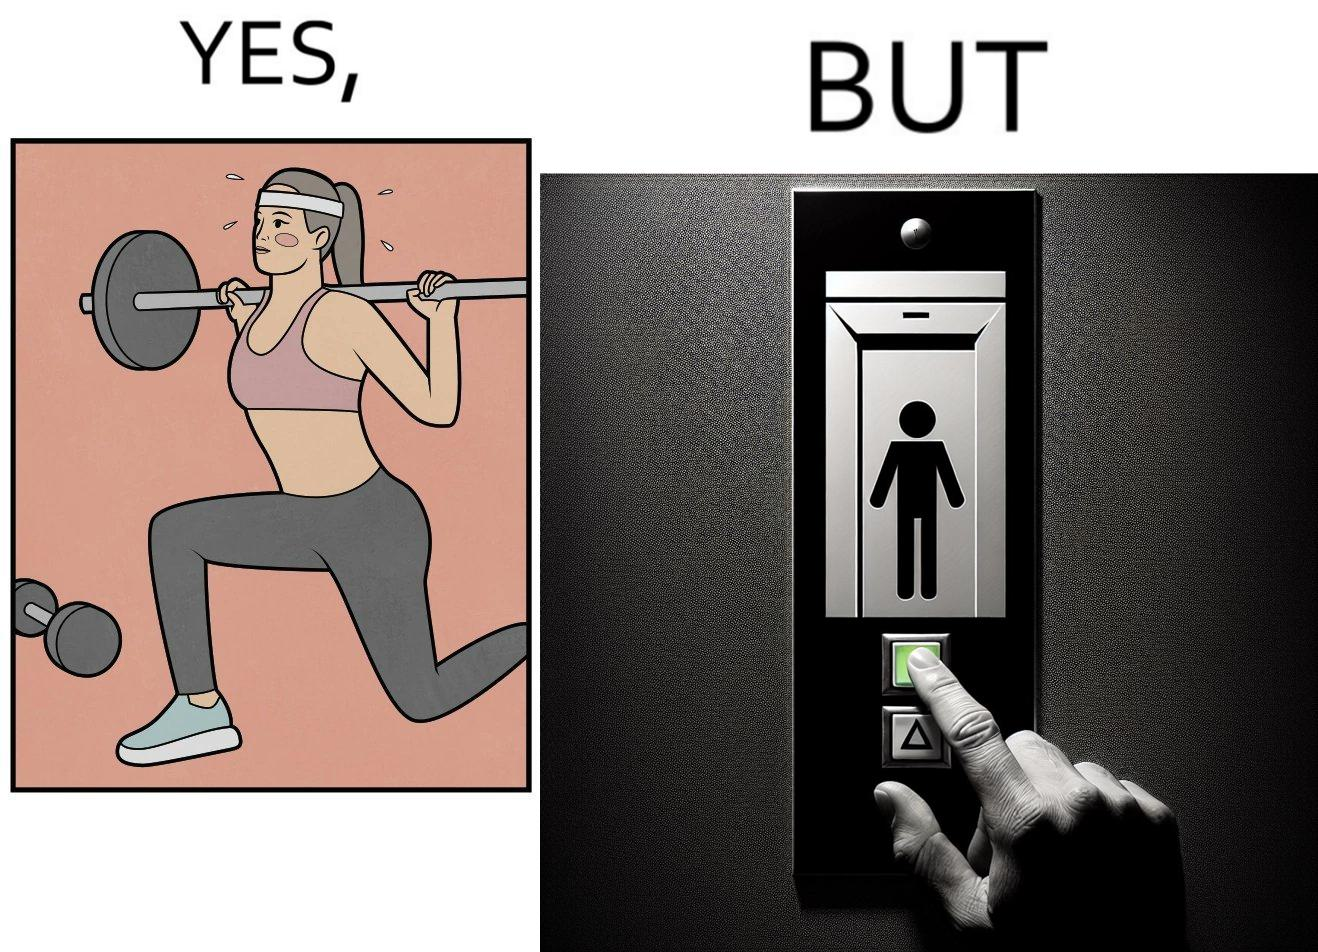What do you see in each half of this image? In the left part of the image: The image shows a women exercising with a bar bell in a gym. She is wearing a sport outfit. She is crouching down on one leg doing a single leg squat with a bar bell. In the right part of the image: The image shows the control panel inside of an elevator. The indicator for the first floor is green which means the button for the first floor was pressed. A hand is about to press the button for the second floor. 